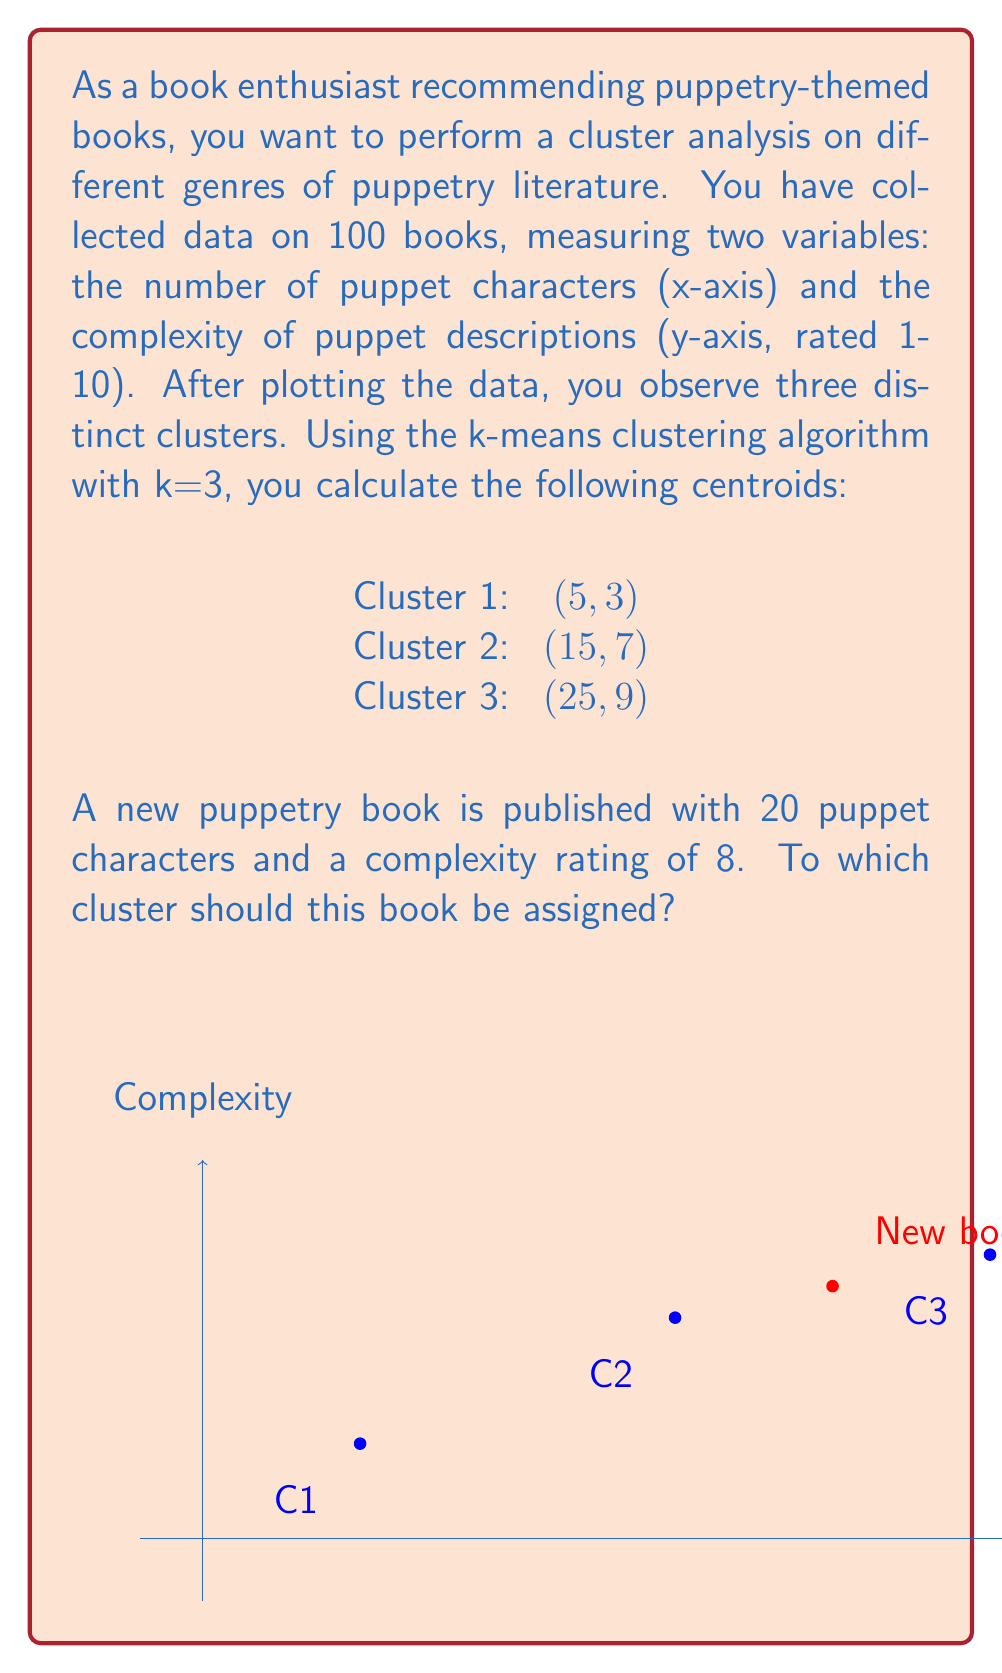Provide a solution to this math problem. To determine which cluster the new book should be assigned to, we need to calculate the Euclidean distance between the new book and each cluster centroid. The book will be assigned to the cluster with the smallest distance.

Let's denote the new book as $P(20, 8)$ and calculate the distance to each centroid:

1. Distance to Cluster 1 centroid $C_1(5, 3)$:
   $$d_1 = \sqrt{(20-5)^2 + (8-3)^2} = \sqrt{225 + 25} = \sqrt{250} \approx 15.81$$

2. Distance to Cluster 2 centroid $C_2(15, 7)$:
   $$d_2 = \sqrt{(20-15)^2 + (8-7)^2} = \sqrt{25 + 1} = \sqrt{26} \approx 5.10$$

3. Distance to Cluster 3 centroid $C_3(25, 9)$:
   $$d_3 = \sqrt{(20-25)^2 + (8-9)^2} = \sqrt{25 + 1} = \sqrt{26} \approx 5.10$$

The smallest distance is shared by Cluster 2 and Cluster 3, both approximately 5.10. In case of a tie, we can assign the book to either cluster. For this question, we'll choose the cluster with the lower index number.
Answer: Cluster 2 